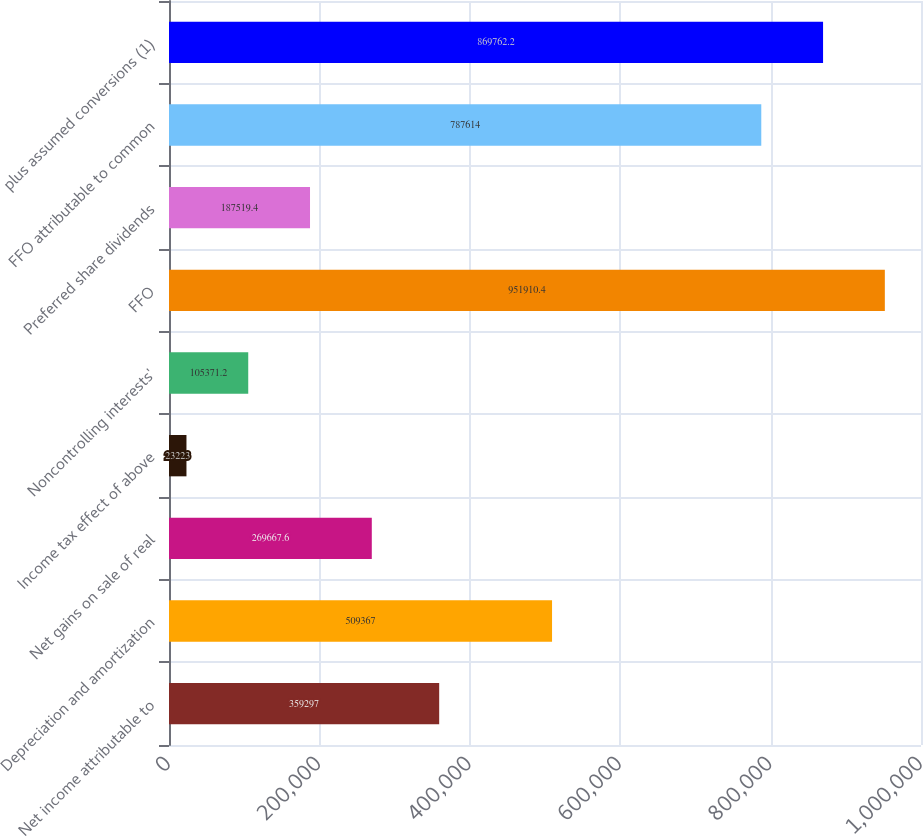Convert chart to OTSL. <chart><loc_0><loc_0><loc_500><loc_500><bar_chart><fcel>Net income attributable to<fcel>Depreciation and amortization<fcel>Net gains on sale of real<fcel>Income tax effect of above<fcel>Noncontrolling interests'<fcel>FFO<fcel>Preferred share dividends<fcel>FFO attributable to common<fcel>plus assumed conversions (1)<nl><fcel>359297<fcel>509367<fcel>269668<fcel>23223<fcel>105371<fcel>951910<fcel>187519<fcel>787614<fcel>869762<nl></chart> 